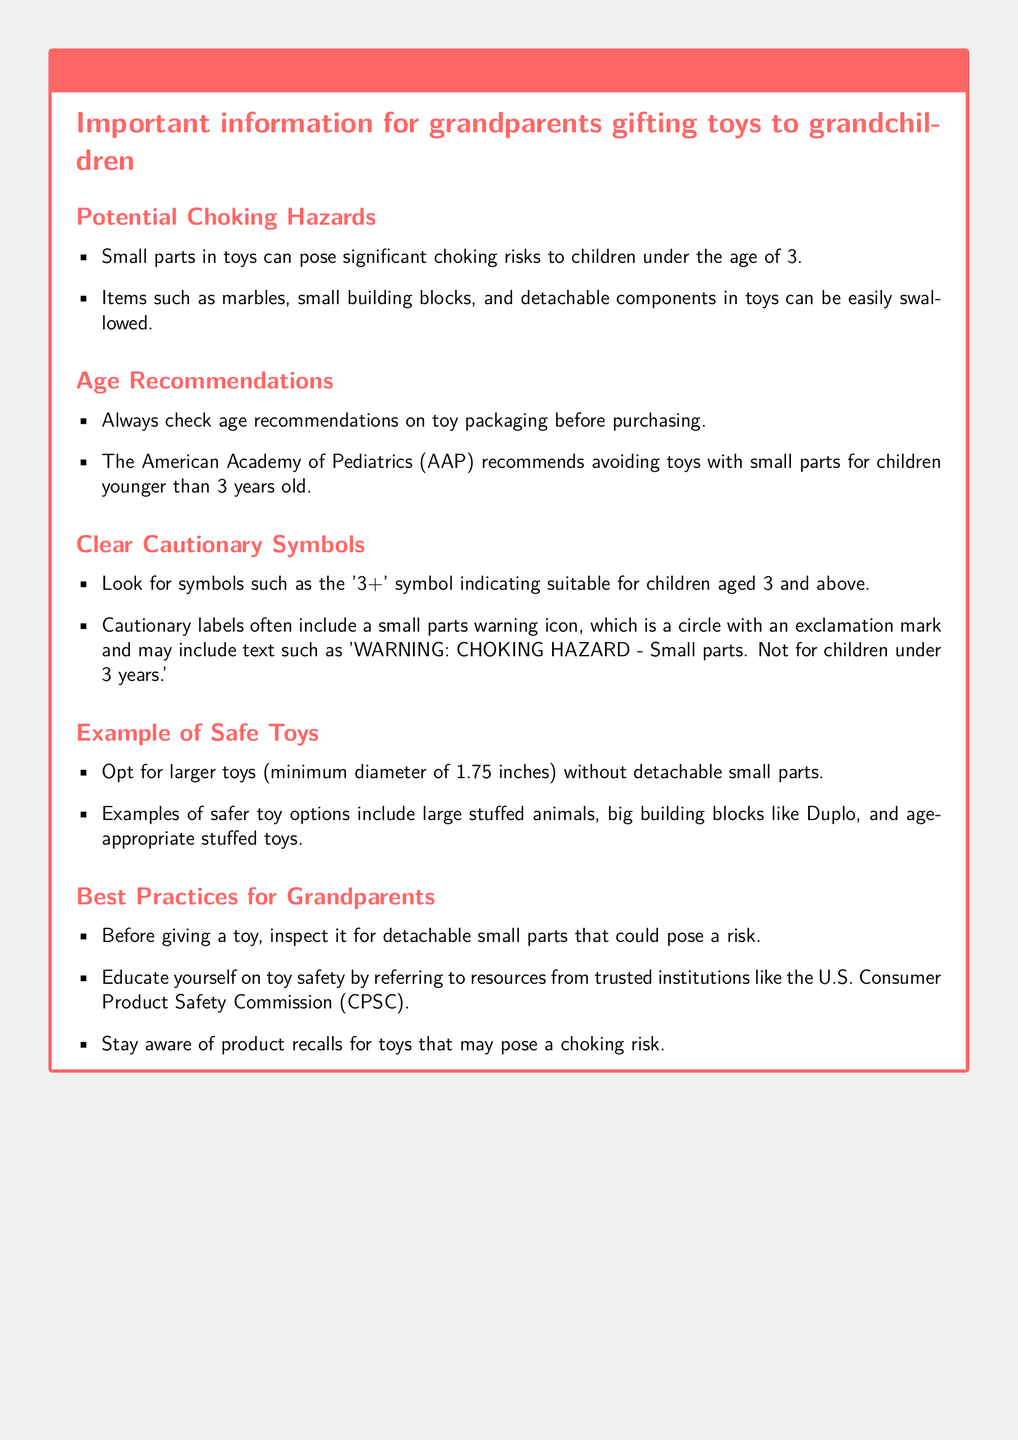What is the age recommendation for small toys? The document states that the American Academy of Pediatrics recommends avoiding toys with small parts for children younger than 3 years old.
Answer: Under 3 years old What should you check before purchasing a toy? The document advises to always check age recommendations on toy packaging before purchasing.
Answer: Age recommendations What is a safe minimum diameter for toys? The document mentions that larger toys should have a minimum diameter of 1.75 inches.
Answer: 1.75 inches What type of toys should be avoided for children under 3? The document specifies that toys with small parts should be avoided.
Answer: Toys with small parts What does the '3+' symbol indicate? The document explains that the '3+' symbol indicates that the toy is suitable for children aged 3 and above.
Answer: Suitable for children aged 3 and above Which organization provides guidance on toy safety? The document refers to the U.S. Consumer Product Safety Commission for toy safety resources.
Answer: U.S. Consumer Product Safety Commission What is an example of a safer toy option? The document lists large stuffed animals as an example of safer toy options.
Answer: Large stuffed animals What feature on packaging warns about choking hazards? The document indicates that packaging often includes a small parts warning icon.
Answer: Small parts warning icon What should grandparents inspect before giving a toy? The document states that grandparents should inspect toys for detachable small parts that could pose a risk.
Answer: Detachable small parts 